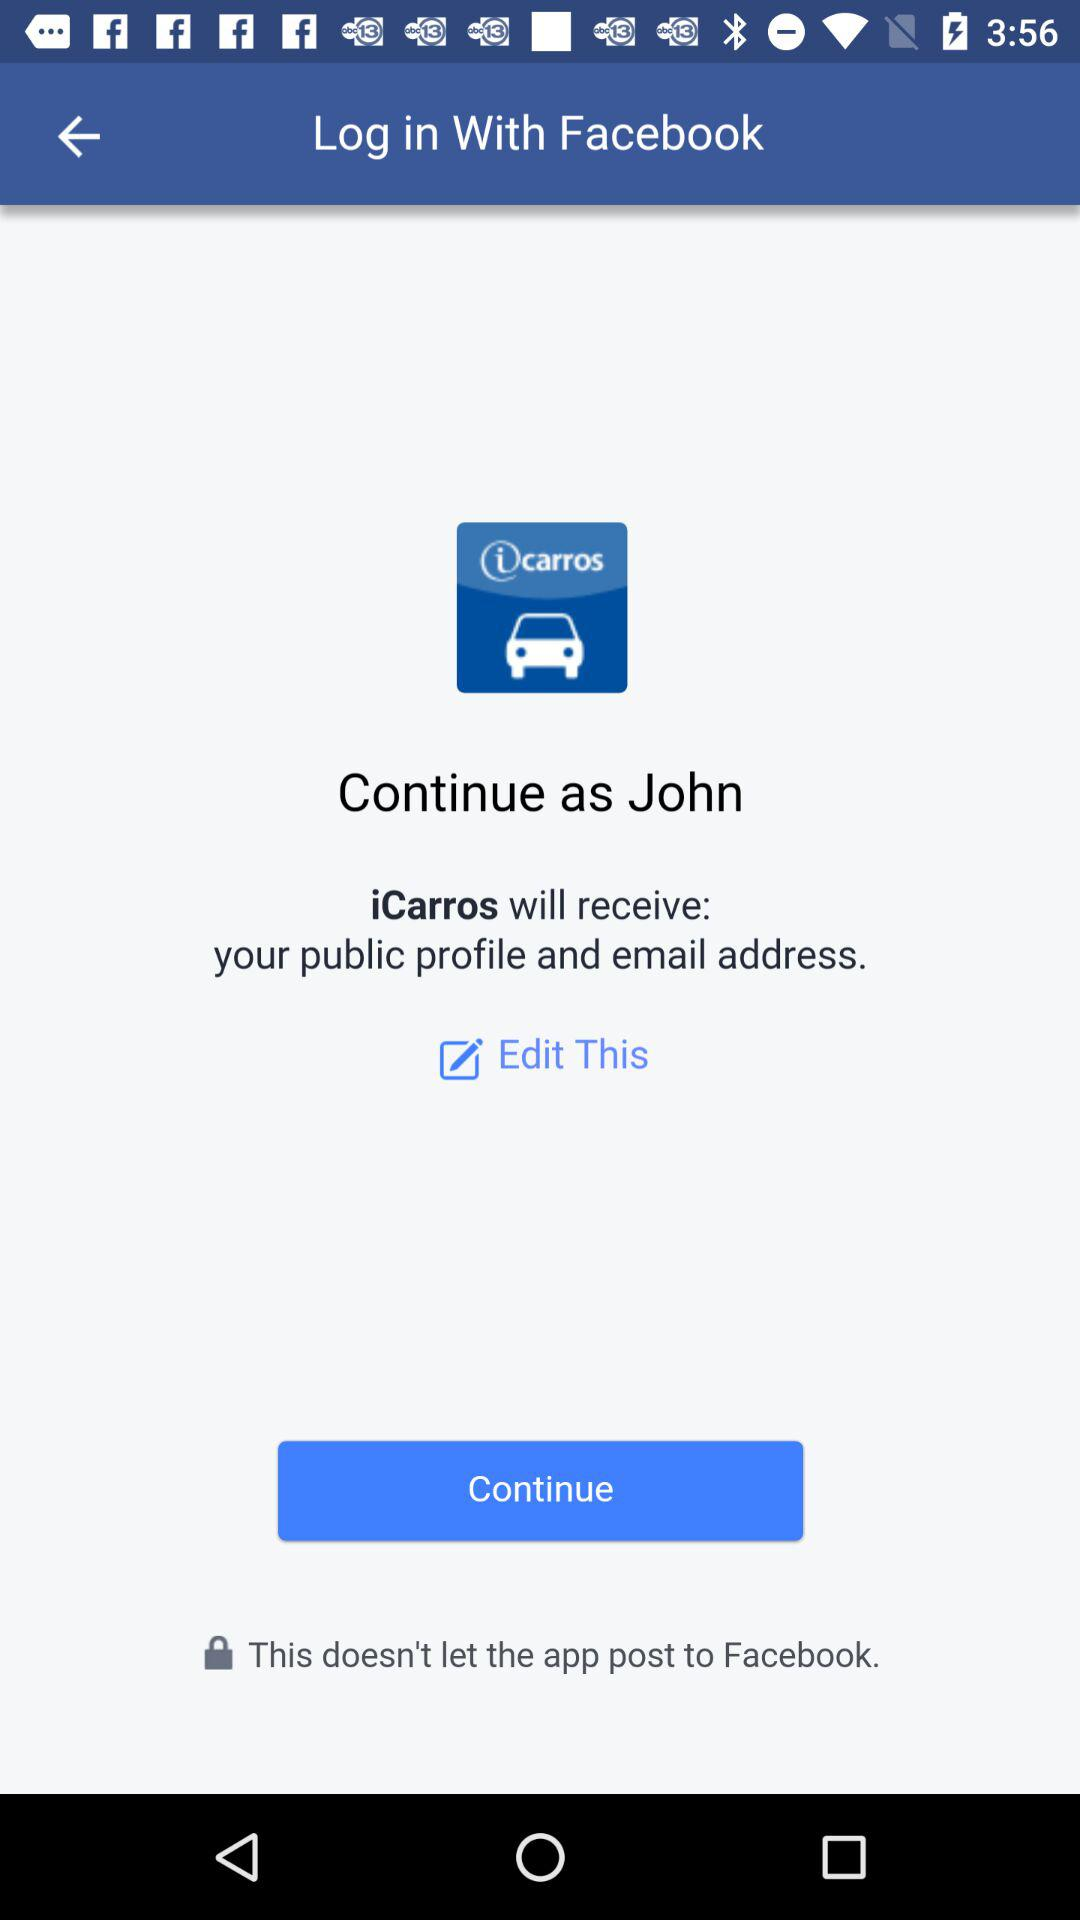What details can we edit? You can edit your "public profile" and "email address". 